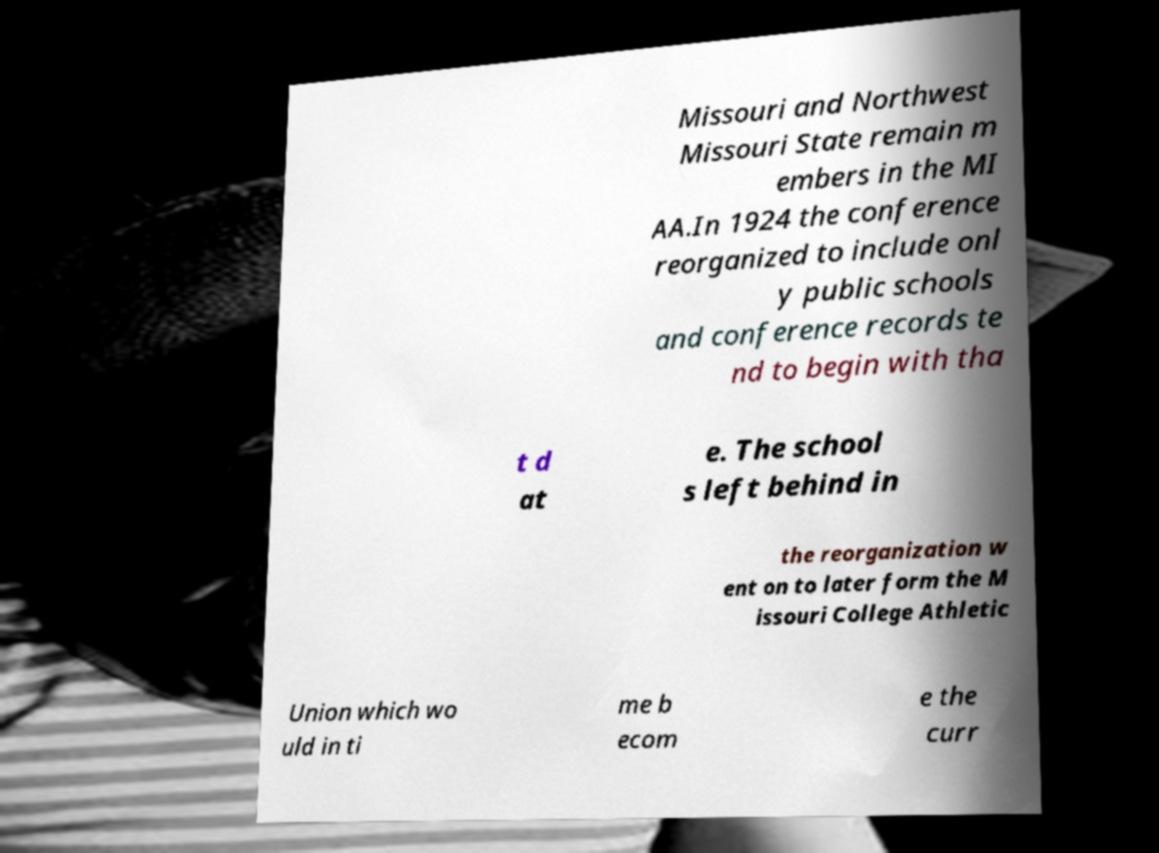I need the written content from this picture converted into text. Can you do that? Missouri and Northwest Missouri State remain m embers in the MI AA.In 1924 the conference reorganized to include onl y public schools and conference records te nd to begin with tha t d at e. The school s left behind in the reorganization w ent on to later form the M issouri College Athletic Union which wo uld in ti me b ecom e the curr 